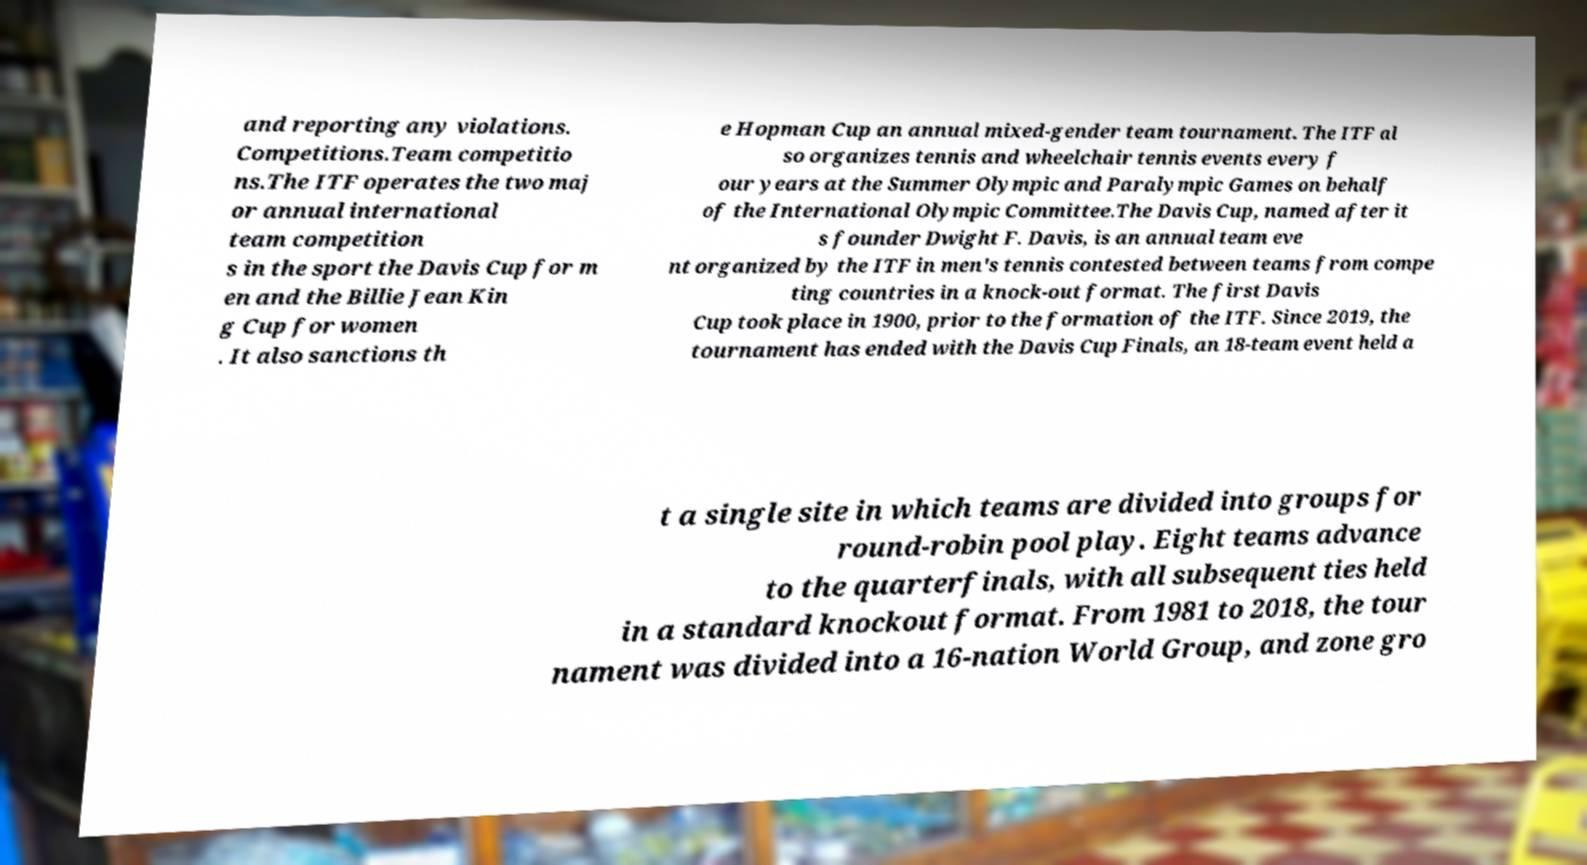Can you accurately transcribe the text from the provided image for me? and reporting any violations. Competitions.Team competitio ns.The ITF operates the two maj or annual international team competition s in the sport the Davis Cup for m en and the Billie Jean Kin g Cup for women . It also sanctions th e Hopman Cup an annual mixed-gender team tournament. The ITF al so organizes tennis and wheelchair tennis events every f our years at the Summer Olympic and Paralympic Games on behalf of the International Olympic Committee.The Davis Cup, named after it s founder Dwight F. Davis, is an annual team eve nt organized by the ITF in men's tennis contested between teams from compe ting countries in a knock-out format. The first Davis Cup took place in 1900, prior to the formation of the ITF. Since 2019, the tournament has ended with the Davis Cup Finals, an 18-team event held a t a single site in which teams are divided into groups for round-robin pool play. Eight teams advance to the quarterfinals, with all subsequent ties held in a standard knockout format. From 1981 to 2018, the tour nament was divided into a 16-nation World Group, and zone gro 